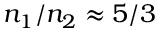Convert formula to latex. <formula><loc_0><loc_0><loc_500><loc_500>n _ { 1 } / n _ { 2 } \approx 5 / 3</formula> 